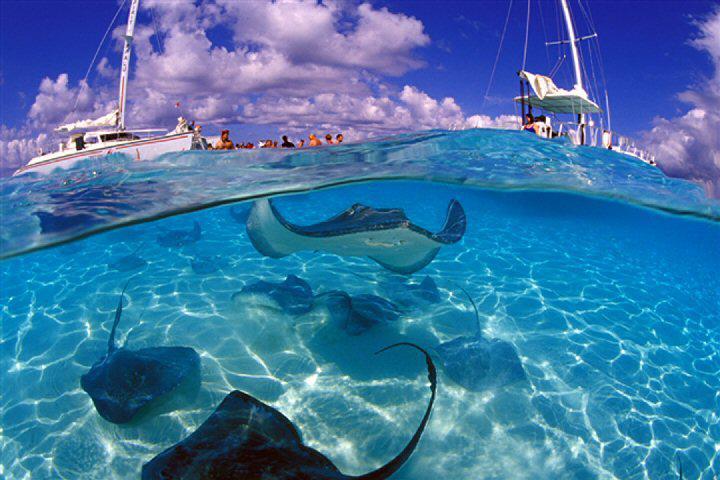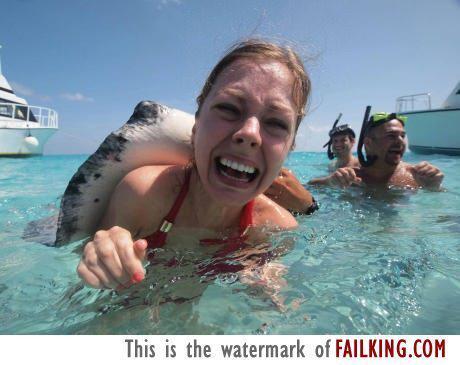The first image is the image on the left, the second image is the image on the right. For the images shown, is this caption "A female in the image on the left is standing in the water with a ray." true? Answer yes or no. No. The first image is the image on the left, the second image is the image on the right. Examine the images to the left and right. Is the description "Left image shows one brown-haired girl interacting with a large light gray stingray." accurate? Answer yes or no. No. 